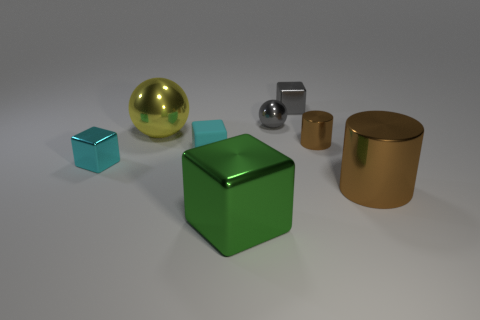Add 2 cyan blocks. How many objects exist? 10 Subtract all cylinders. How many objects are left? 6 Subtract 0 gray cylinders. How many objects are left? 8 Subtract all small gray blocks. Subtract all large brown shiny things. How many objects are left? 6 Add 7 tiny metal spheres. How many tiny metal spheres are left? 8 Add 3 large red metal balls. How many large red metal balls exist? 3 